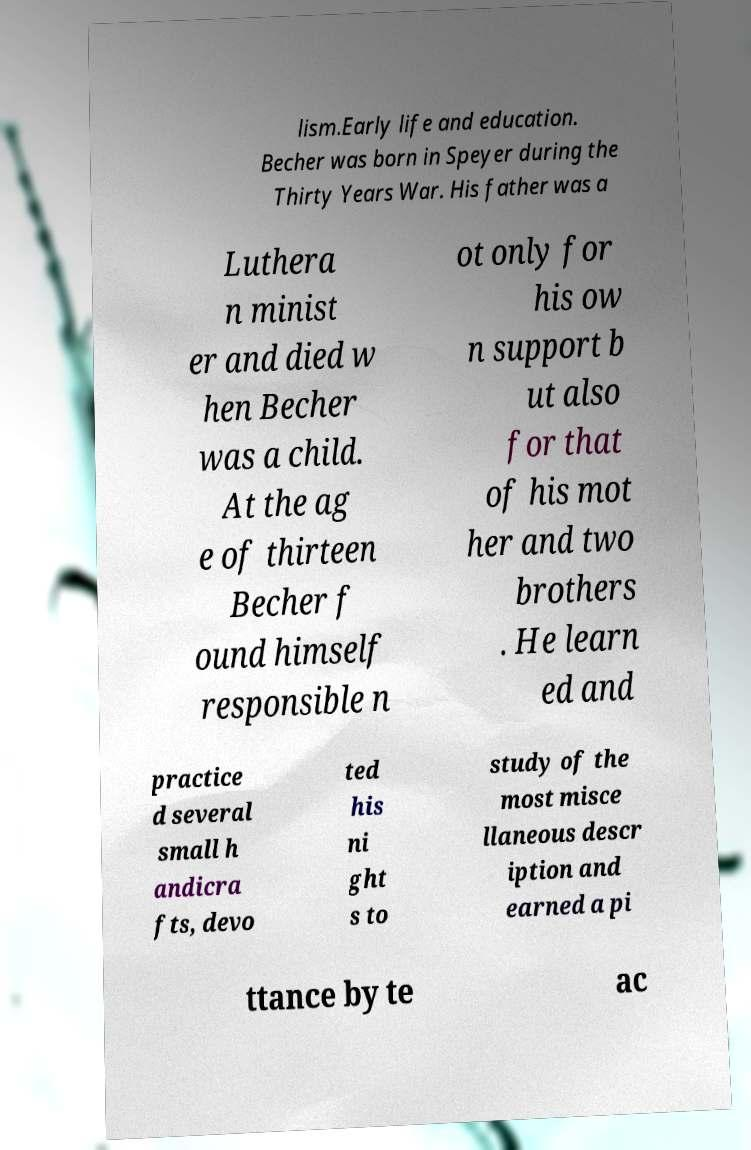There's text embedded in this image that I need extracted. Can you transcribe it verbatim? lism.Early life and education. Becher was born in Speyer during the Thirty Years War. His father was a Luthera n minist er and died w hen Becher was a child. At the ag e of thirteen Becher f ound himself responsible n ot only for his ow n support b ut also for that of his mot her and two brothers . He learn ed and practice d several small h andicra fts, devo ted his ni ght s to study of the most misce llaneous descr iption and earned a pi ttance by te ac 